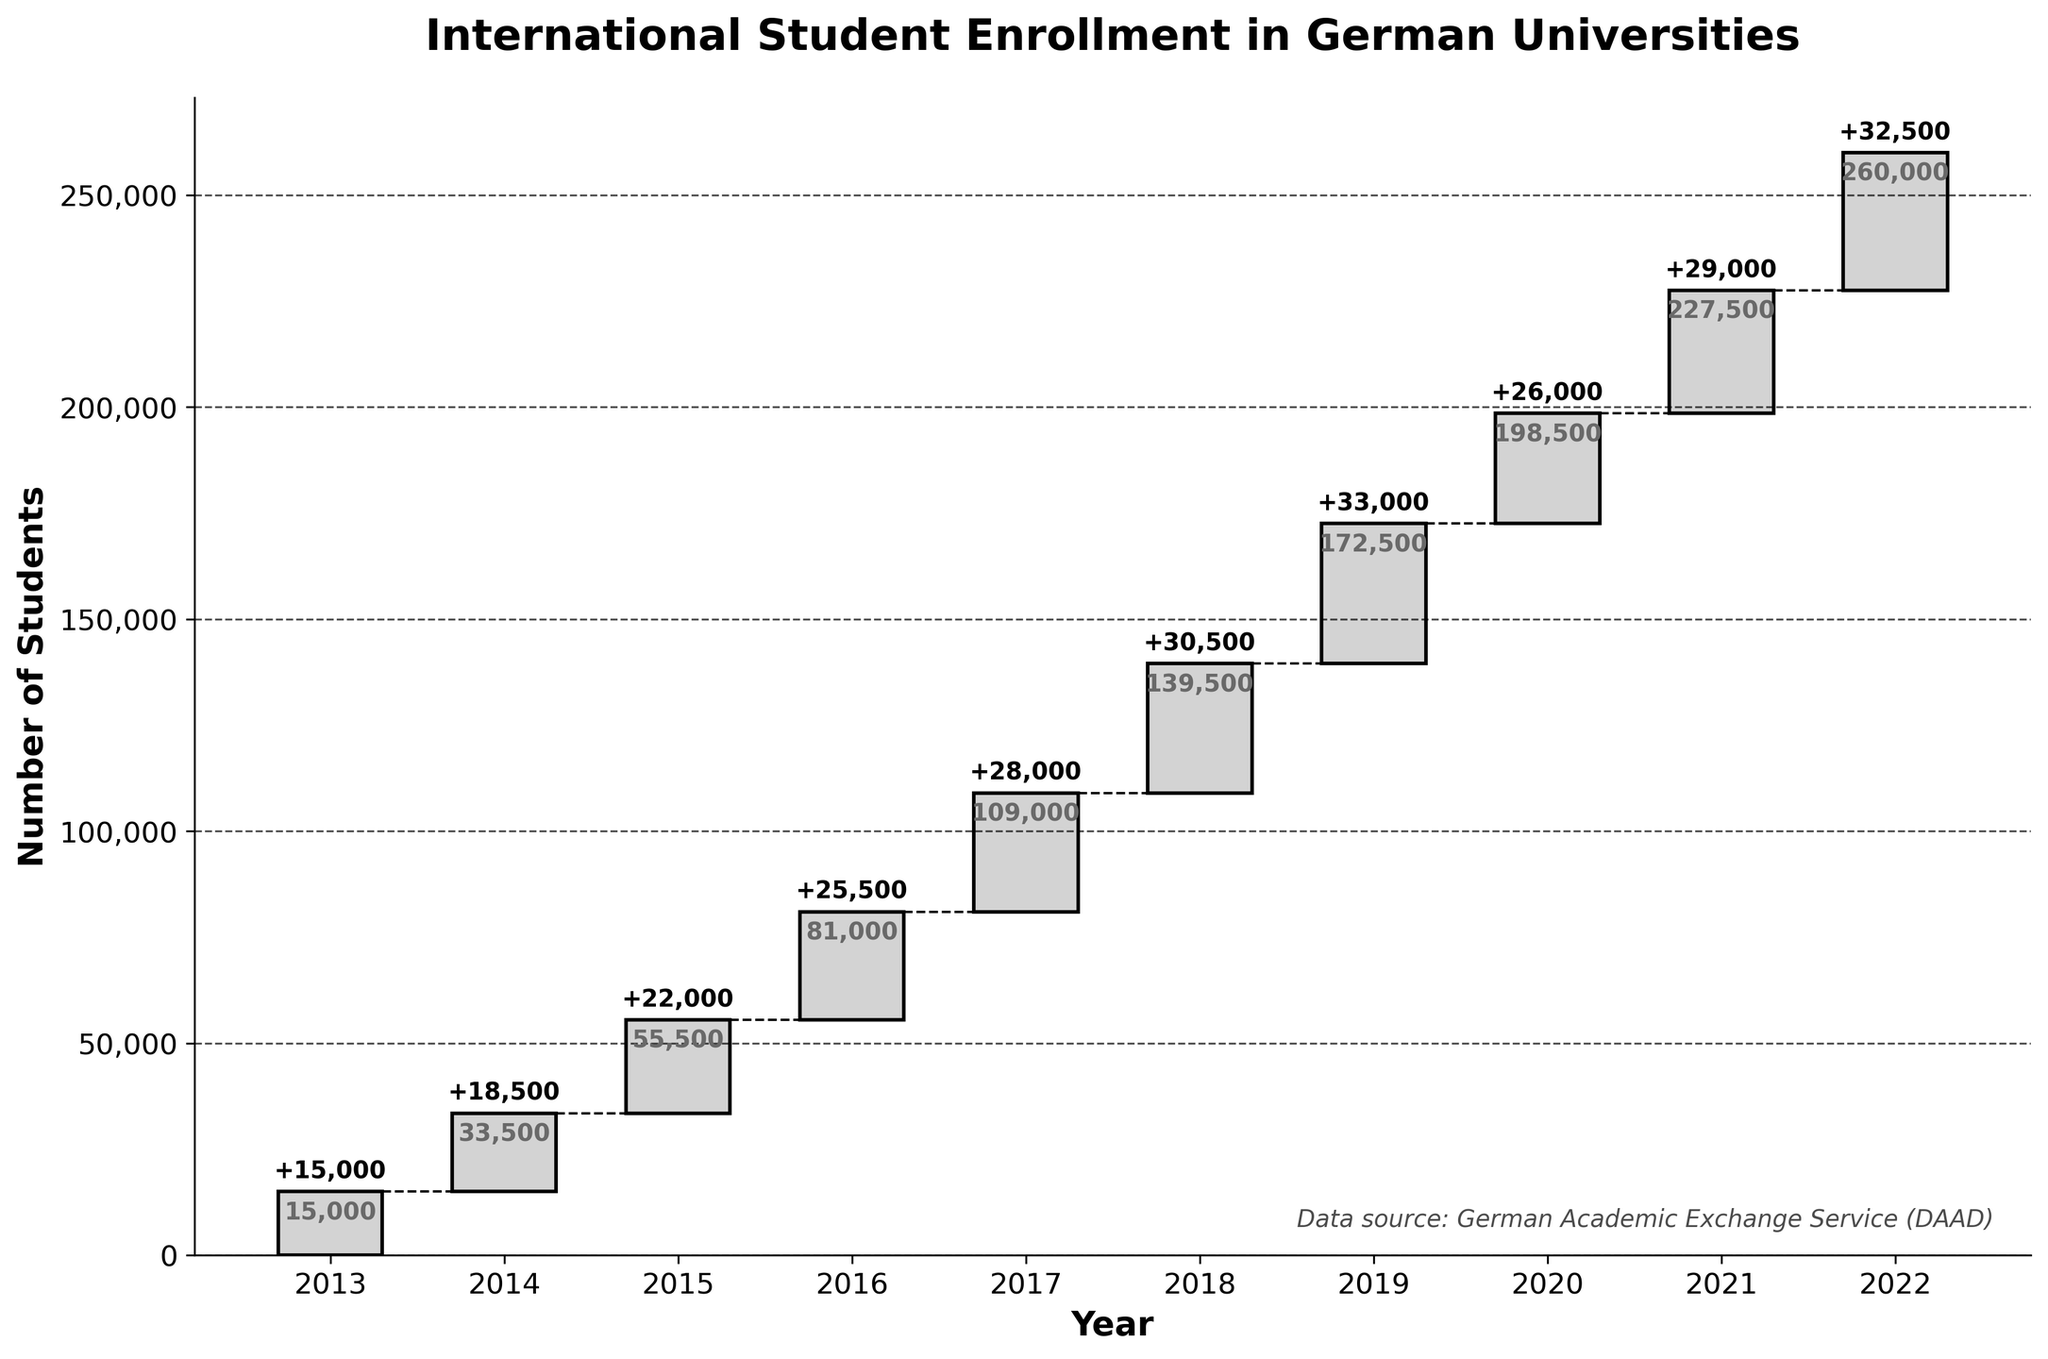What's the title of the figure? The title is at the top of the figure, usually in larger or bold font. In this case, it reads "International Student Enrollment in German Universities".
Answer: International Student Enrollment in German Universities In which year was the smallest increase in student enrollment observed? By looking at the 'Change' bars in the figure, the smallest bar corresponds to the year 2013, where the change is listed.
Answer: 2013 What is the cumulative number of students at the end of 2020? The cumulative total for each year is shown at the top of the cumulative bars. For 2020, the cumulative number is directly above or on the bar for that year.
Answer: 198,500 How many years had a yearly increase of more than 30,000 students? Identify the bars where the 'Change' value is greater than 30,000 and count them.
Answer: 4 What was the total increase in student enrollment from 2013 to 2015? Add the 'Change' values for 2013, 2014, and 2015. 15,000 + 18,500 + 22,000.
Answer: 55,500 Which year saw a higher increase in enrollment, 2016 or 2018? Compare the 'Change' bars for 2016 and 2018. 2016 has a change of 25,500 and 2018 has a change of 30,500, making 2018 higher.
Answer: 2018 Between which years did the cumulative number of students first exceed 100,000? Identify the first cumulative value that exceeds 100,000 and check the years before and after it. In 2017, it passes 100,000 as the cumulative number is 109,000.
Answer: 2016 and 2017 What was the total cumulative number of students at the end of 2022? The cumulative figure for 2022 is shown at the top of the cumulative bar for that year.
Answer: 260,000 